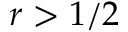<formula> <loc_0><loc_0><loc_500><loc_500>r > 1 / 2</formula> 